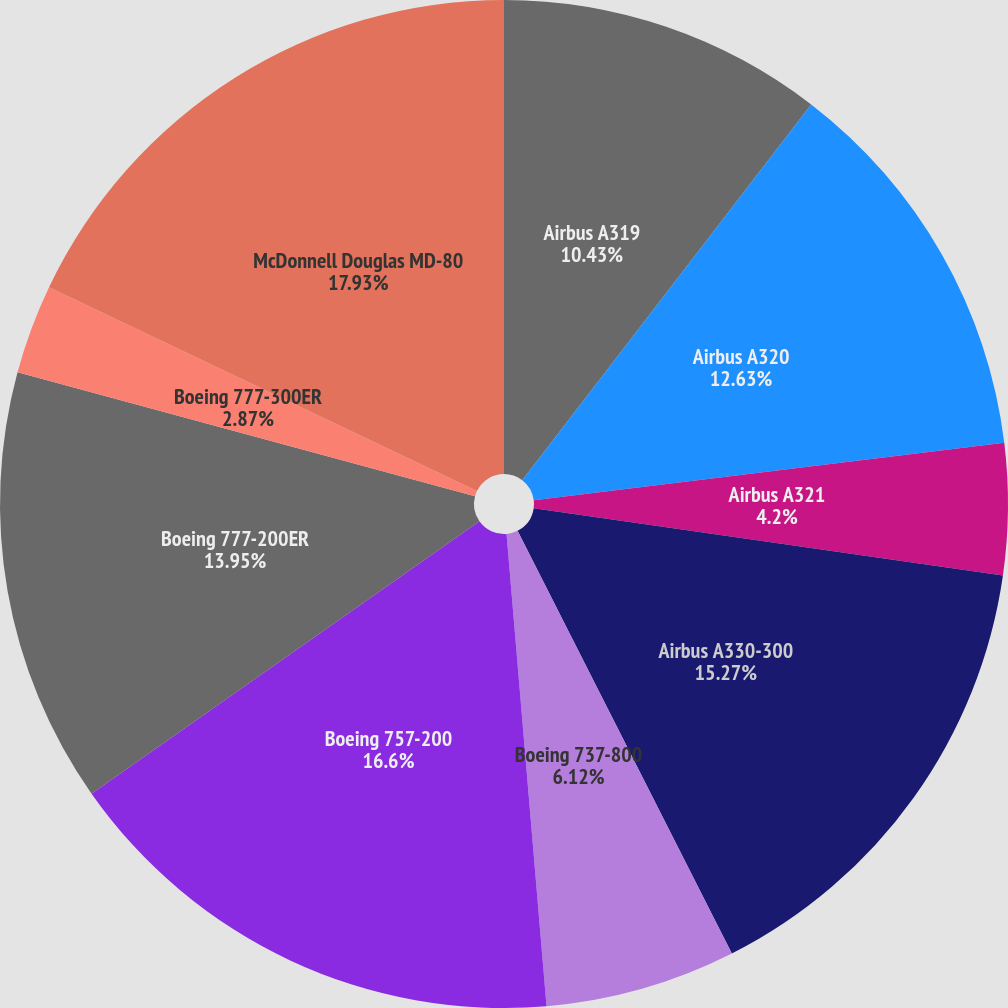Convert chart to OTSL. <chart><loc_0><loc_0><loc_500><loc_500><pie_chart><fcel>Airbus A319<fcel>Airbus A320<fcel>Airbus A321<fcel>Airbus A330-300<fcel>Boeing 737-800<fcel>Boeing 757-200<fcel>Boeing 777-200ER<fcel>Boeing 777-300ER<fcel>McDonnell Douglas MD-80<nl><fcel>10.43%<fcel>12.63%<fcel>4.2%<fcel>15.27%<fcel>6.12%<fcel>16.6%<fcel>13.95%<fcel>2.87%<fcel>17.92%<nl></chart> 